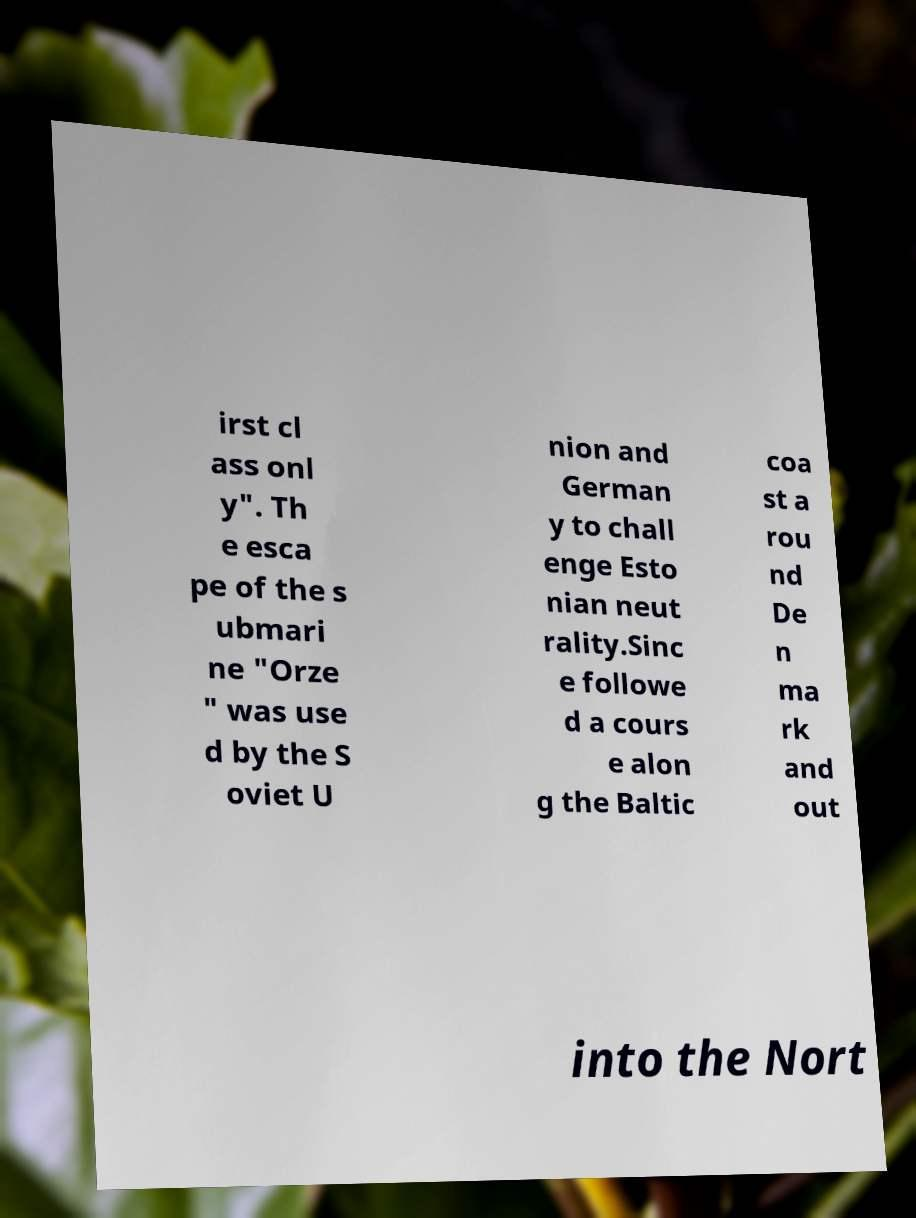I need the written content from this picture converted into text. Can you do that? irst cl ass onl y". Th e esca pe of the s ubmari ne "Orze " was use d by the S oviet U nion and German y to chall enge Esto nian neut rality.Sinc e followe d a cours e alon g the Baltic coa st a rou nd De n ma rk and out into the Nort 